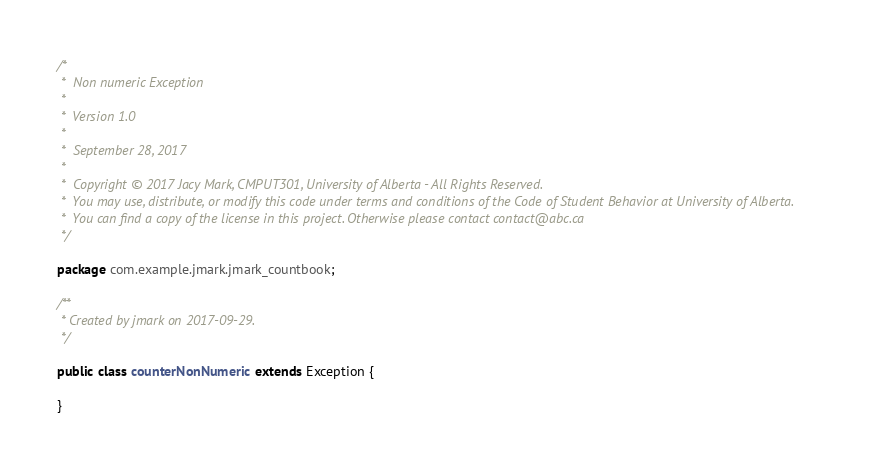<code> <loc_0><loc_0><loc_500><loc_500><_Java_>
/*
 *  Non numeric Exception
 *
 *  Version 1.0
 *
 *  September 28, 2017
 *
 *  Copyright © 2017 Jacy Mark, CMPUT301, University of Alberta - All Rights Reserved.
 *  You may use, distribute, or modify this code under terms and conditions of the Code of Student Behavior at University of Alberta.
 *  You can find a copy of the license in this project. Otherwise please contact contact@abc.ca
 */

package com.example.jmark.jmark_countbook;

/**
 * Created by jmark on 2017-09-29.
 */

public class counterNonNumeric extends Exception {

}
</code> 